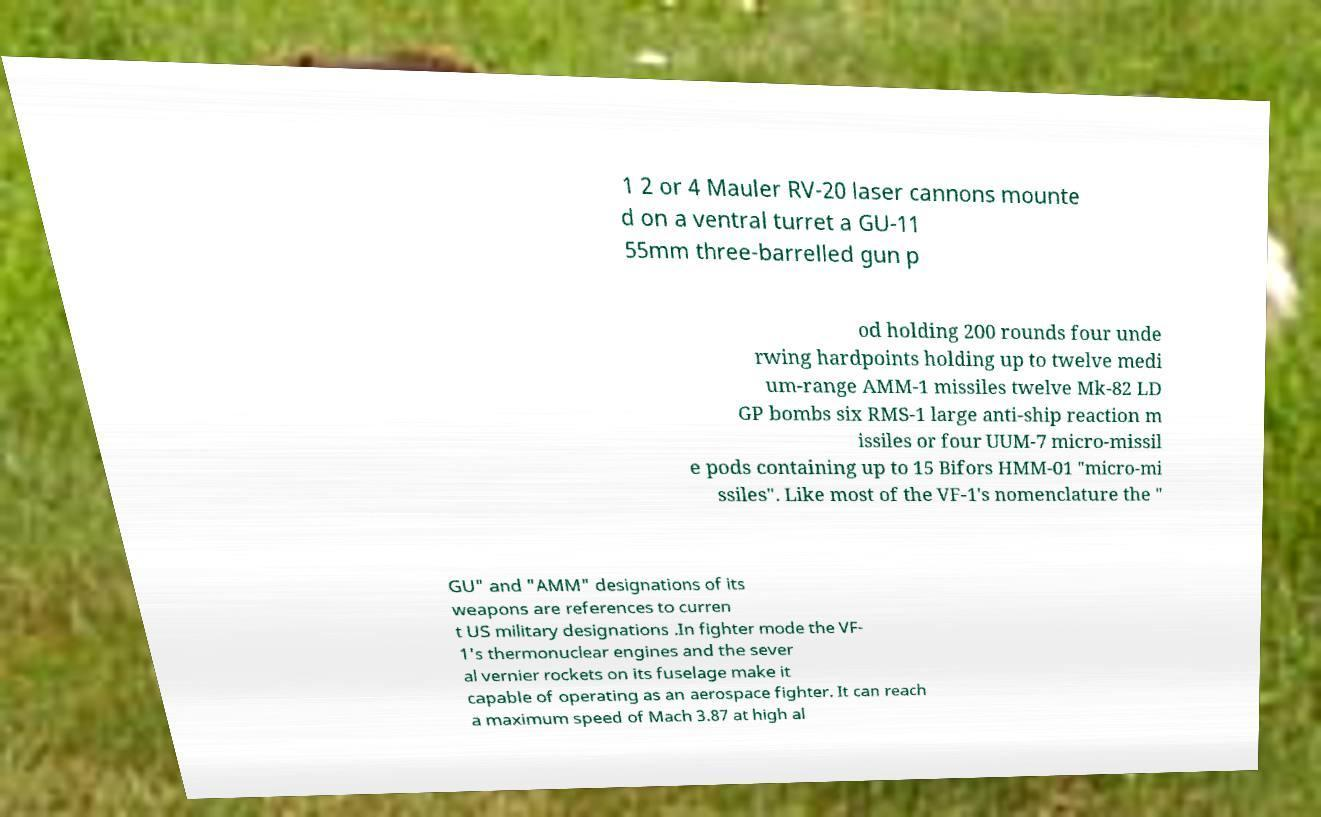For documentation purposes, I need the text within this image transcribed. Could you provide that? 1 2 or 4 Mauler RV-20 laser cannons mounte d on a ventral turret a GU-11 55mm three-barrelled gun p od holding 200 rounds four unde rwing hardpoints holding up to twelve medi um-range AMM-1 missiles twelve Mk-82 LD GP bombs six RMS-1 large anti-ship reaction m issiles or four UUM-7 micro-missil e pods containing up to 15 Bifors HMM-01 "micro-mi ssiles". Like most of the VF-1's nomenclature the " GU" and "AMM" designations of its weapons are references to curren t US military designations .In fighter mode the VF- 1's thermonuclear engines and the sever al vernier rockets on its fuselage make it capable of operating as an aerospace fighter. It can reach a maximum speed of Mach 3.87 at high al 